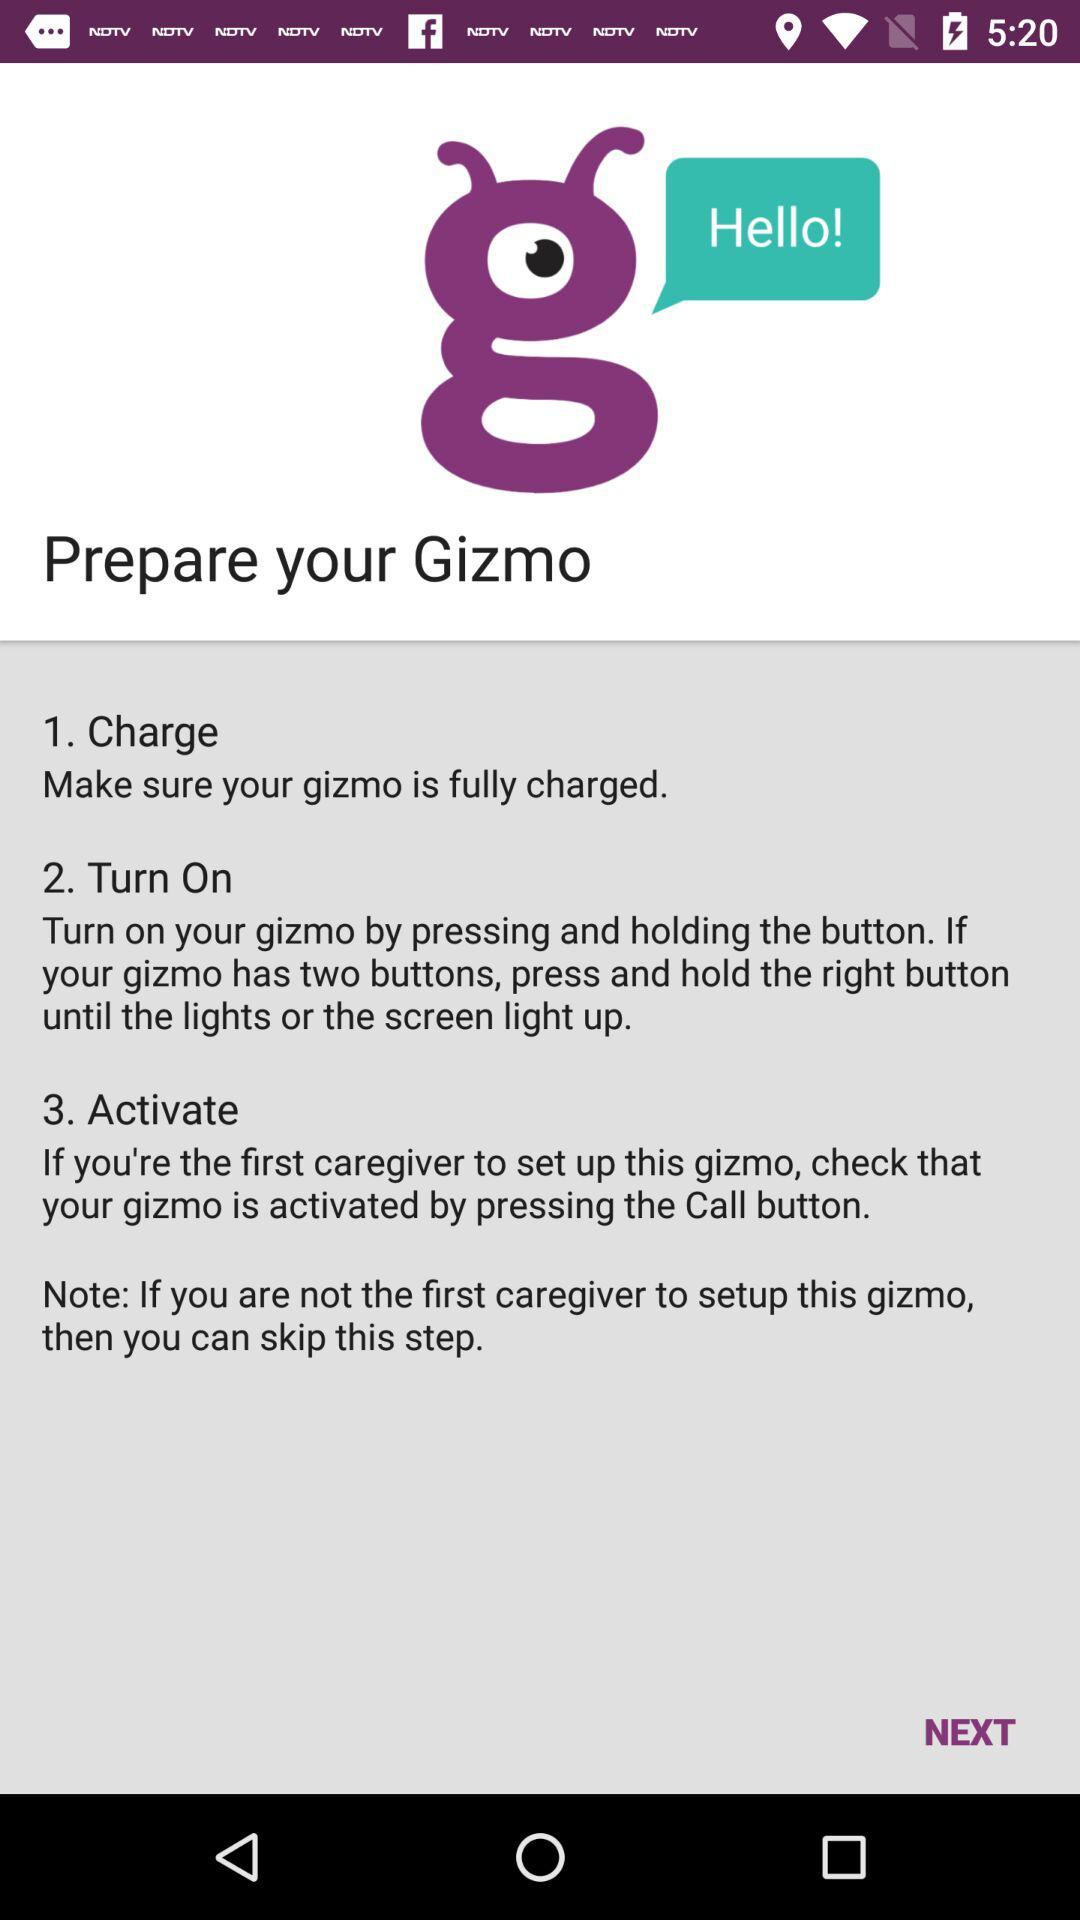How many steps are there in the process if you are not the first caregiver?
Answer the question using a single word or phrase. 2 